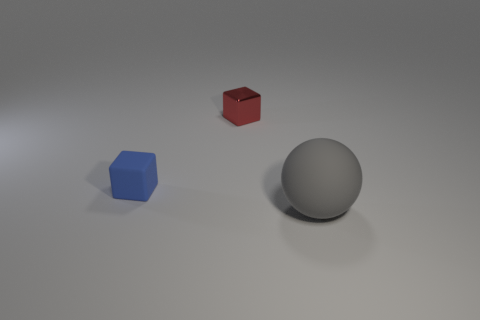Subtract all blue cubes. How many cubes are left? 1 Subtract all purple spheres. Subtract all cyan cubes. How many spheres are left? 1 Subtract all yellow spheres. How many blue blocks are left? 1 Subtract all tiny yellow metallic balls. Subtract all blocks. How many objects are left? 1 Add 2 gray balls. How many gray balls are left? 3 Add 3 rubber things. How many rubber things exist? 5 Add 3 matte blocks. How many objects exist? 6 Subtract 0 blue cylinders. How many objects are left? 3 Subtract all cubes. How many objects are left? 1 